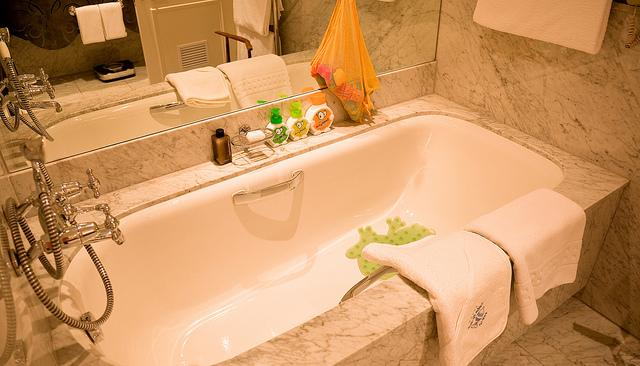Who likely uses this bathtub? Please explain your reasoning. children. There are toys and brightly colored soaps in the bathtub that would be suitable for a child. 